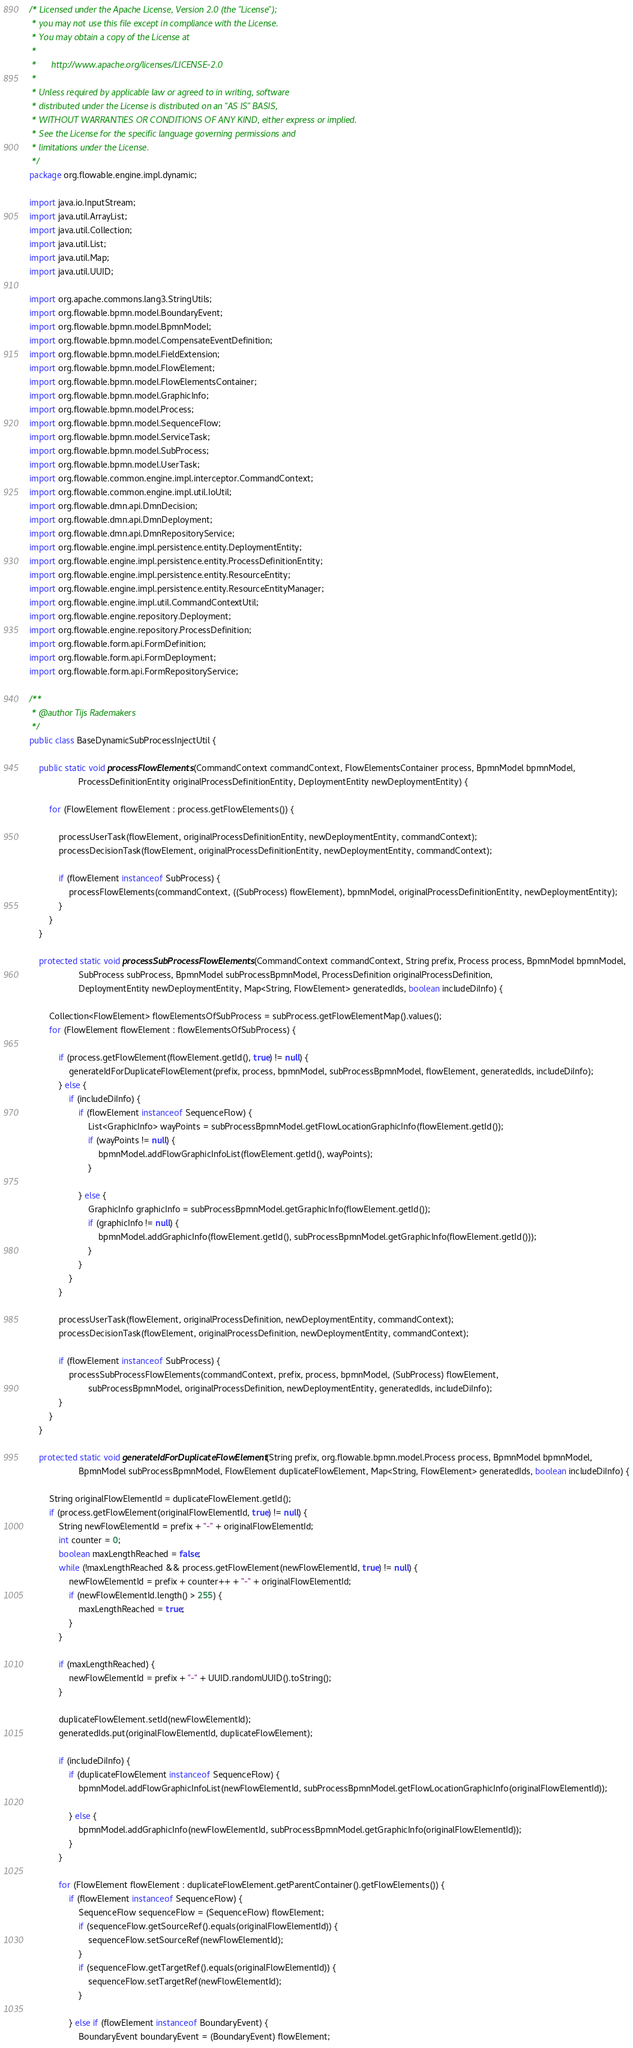<code> <loc_0><loc_0><loc_500><loc_500><_Java_>/* Licensed under the Apache License, Version 2.0 (the "License");
 * you may not use this file except in compliance with the License.
 * You may obtain a copy of the License at
 * 
 *      http://www.apache.org/licenses/LICENSE-2.0
 * 
 * Unless required by applicable law or agreed to in writing, software
 * distributed under the License is distributed on an "AS IS" BASIS,
 * WITHOUT WARRANTIES OR CONDITIONS OF ANY KIND, either express or implied.
 * See the License for the specific language governing permissions and
 * limitations under the License.
 */
package org.flowable.engine.impl.dynamic;

import java.io.InputStream;
import java.util.ArrayList;
import java.util.Collection;
import java.util.List;
import java.util.Map;
import java.util.UUID;

import org.apache.commons.lang3.StringUtils;
import org.flowable.bpmn.model.BoundaryEvent;
import org.flowable.bpmn.model.BpmnModel;
import org.flowable.bpmn.model.CompensateEventDefinition;
import org.flowable.bpmn.model.FieldExtension;
import org.flowable.bpmn.model.FlowElement;
import org.flowable.bpmn.model.FlowElementsContainer;
import org.flowable.bpmn.model.GraphicInfo;
import org.flowable.bpmn.model.Process;
import org.flowable.bpmn.model.SequenceFlow;
import org.flowable.bpmn.model.ServiceTask;
import org.flowable.bpmn.model.SubProcess;
import org.flowable.bpmn.model.UserTask;
import org.flowable.common.engine.impl.interceptor.CommandContext;
import org.flowable.common.engine.impl.util.IoUtil;
import org.flowable.dmn.api.DmnDecision;
import org.flowable.dmn.api.DmnDeployment;
import org.flowable.dmn.api.DmnRepositoryService;
import org.flowable.engine.impl.persistence.entity.DeploymentEntity;
import org.flowable.engine.impl.persistence.entity.ProcessDefinitionEntity;
import org.flowable.engine.impl.persistence.entity.ResourceEntity;
import org.flowable.engine.impl.persistence.entity.ResourceEntityManager;
import org.flowable.engine.impl.util.CommandContextUtil;
import org.flowable.engine.repository.Deployment;
import org.flowable.engine.repository.ProcessDefinition;
import org.flowable.form.api.FormDefinition;
import org.flowable.form.api.FormDeployment;
import org.flowable.form.api.FormRepositoryService;

/**
 * @author Tijs Rademakers
 */
public class BaseDynamicSubProcessInjectUtil {
    
    public static void processFlowElements(CommandContext commandContext, FlowElementsContainer process, BpmnModel bpmnModel, 
                    ProcessDefinitionEntity originalProcessDefinitionEntity, DeploymentEntity newDeploymentEntity) {
        
        for (FlowElement flowElement : process.getFlowElements()) {

            processUserTask(flowElement, originalProcessDefinitionEntity, newDeploymentEntity, commandContext);
            processDecisionTask(flowElement, originalProcessDefinitionEntity, newDeploymentEntity, commandContext);
                
            if (flowElement instanceof SubProcess) {
                processFlowElements(commandContext, ((SubProcess) flowElement), bpmnModel, originalProcessDefinitionEntity, newDeploymentEntity);
            }
        }
    }
    
    protected static void processSubProcessFlowElements(CommandContext commandContext, String prefix, Process process, BpmnModel bpmnModel, 
                    SubProcess subProcess, BpmnModel subProcessBpmnModel, ProcessDefinition originalProcessDefinition, 
                    DeploymentEntity newDeploymentEntity, Map<String, FlowElement> generatedIds, boolean includeDiInfo) {
        
        Collection<FlowElement> flowElementsOfSubProcess = subProcess.getFlowElementMap().values(); 
        for (FlowElement flowElement : flowElementsOfSubProcess) {

            if (process.getFlowElement(flowElement.getId(), true) != null) {
                generateIdForDuplicateFlowElement(prefix, process, bpmnModel, subProcessBpmnModel, flowElement, generatedIds, includeDiInfo);
            } else {
                if (includeDiInfo) {
                    if (flowElement instanceof SequenceFlow) {
                        List<GraphicInfo> wayPoints = subProcessBpmnModel.getFlowLocationGraphicInfo(flowElement.getId());
                        if (wayPoints != null) {
                            bpmnModel.addFlowGraphicInfoList(flowElement.getId(), wayPoints);
                        }
                        
                    } else {
                        GraphicInfo graphicInfo = subProcessBpmnModel.getGraphicInfo(flowElement.getId());
                        if (graphicInfo != null) {
                            bpmnModel.addGraphicInfo(flowElement.getId(), subProcessBpmnModel.getGraphicInfo(flowElement.getId()));
                        }
                    }
                }
            }
            
            processUserTask(flowElement, originalProcessDefinition, newDeploymentEntity, commandContext);
            processDecisionTask(flowElement, originalProcessDefinition, newDeploymentEntity, commandContext);

            if (flowElement instanceof SubProcess) {
                processSubProcessFlowElements(commandContext, prefix, process, bpmnModel, (SubProcess) flowElement, 
                        subProcessBpmnModel, originalProcessDefinition, newDeploymentEntity, generatedIds, includeDiInfo);
            }
        }
    }
    
    protected static void generateIdForDuplicateFlowElement(String prefix, org.flowable.bpmn.model.Process process, BpmnModel bpmnModel, 
                    BpmnModel subProcessBpmnModel, FlowElement duplicateFlowElement, Map<String, FlowElement> generatedIds, boolean includeDiInfo) {
        
        String originalFlowElementId = duplicateFlowElement.getId();
        if (process.getFlowElement(originalFlowElementId, true) != null) {
            String newFlowElementId = prefix + "-" + originalFlowElementId;
            int counter = 0;
            boolean maxLengthReached = false;
            while (!maxLengthReached && process.getFlowElement(newFlowElementId, true) != null) {
                newFlowElementId = prefix + counter++ + "-" + originalFlowElementId;
                if (newFlowElementId.length() > 255) {
                    maxLengthReached = true;
                }
            }

            if (maxLengthReached) {
                newFlowElementId = prefix + "-" + UUID.randomUUID().toString();
            }

            duplicateFlowElement.setId(newFlowElementId);
            generatedIds.put(originalFlowElementId, duplicateFlowElement);
            
            if (includeDiInfo) {
                if (duplicateFlowElement instanceof SequenceFlow) {
                    bpmnModel.addFlowGraphicInfoList(newFlowElementId, subProcessBpmnModel.getFlowLocationGraphicInfo(originalFlowElementId));
                    
                } else {
                    bpmnModel.addGraphicInfo(newFlowElementId, subProcessBpmnModel.getGraphicInfo(originalFlowElementId));
                }
            }

            for (FlowElement flowElement : duplicateFlowElement.getParentContainer().getFlowElements()) {
                if (flowElement instanceof SequenceFlow) {
                    SequenceFlow sequenceFlow = (SequenceFlow) flowElement; 
                    if (sequenceFlow.getSourceRef().equals(originalFlowElementId)) {
                        sequenceFlow.setSourceRef(newFlowElementId);
                    }
                    if (sequenceFlow.getTargetRef().equals(originalFlowElementId)) {
                        sequenceFlow.setTargetRef(newFlowElementId);
                    }

                } else if (flowElement instanceof BoundaryEvent) {
                    BoundaryEvent boundaryEvent = (BoundaryEvent) flowElement;</code> 